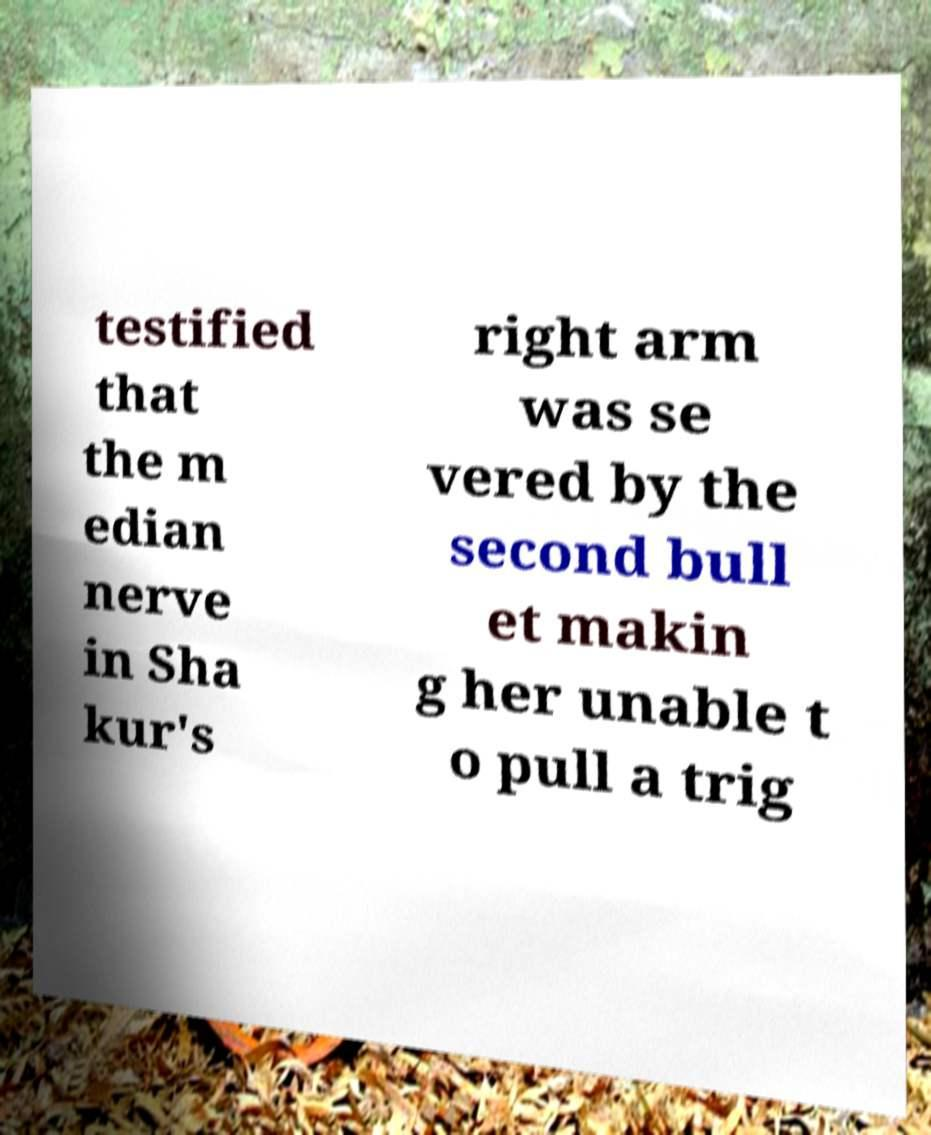Please identify and transcribe the text found in this image. testified that the m edian nerve in Sha kur's right arm was se vered by the second bull et makin g her unable t o pull a trig 